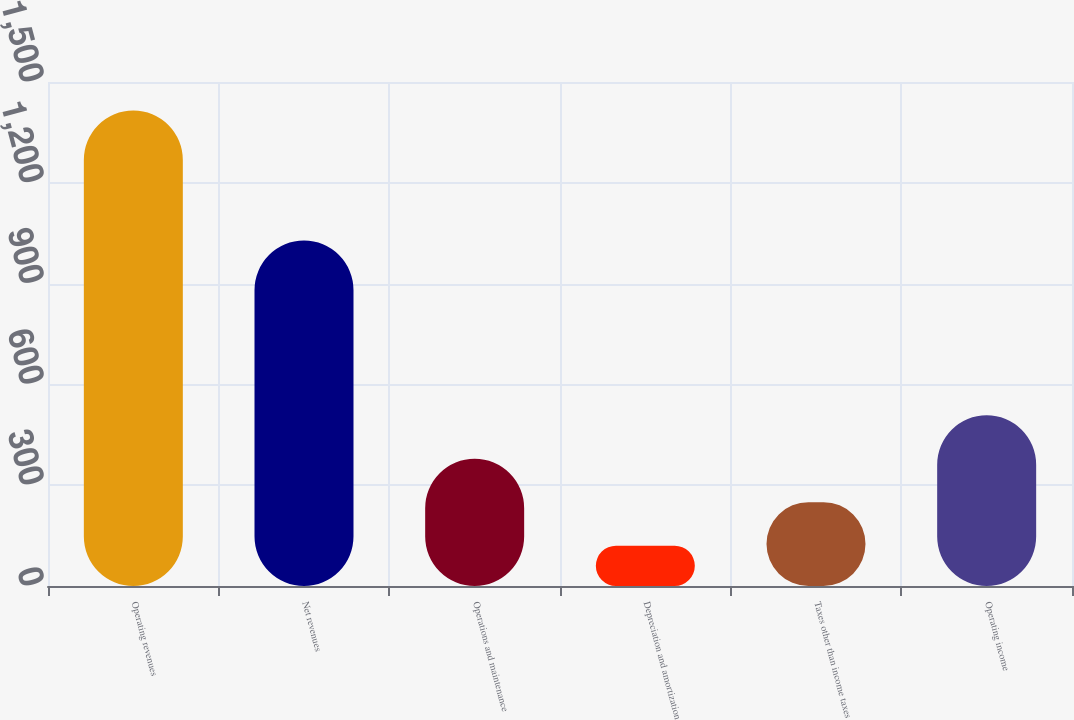<chart> <loc_0><loc_0><loc_500><loc_500><bar_chart><fcel>Operating revenues<fcel>Net revenues<fcel>Operations and maintenance<fcel>Depreciation and amortization<fcel>Taxes other than income taxes<fcel>Operating income<nl><fcel>1415<fcel>1028<fcel>379<fcel>120<fcel>249.5<fcel>508.5<nl></chart> 